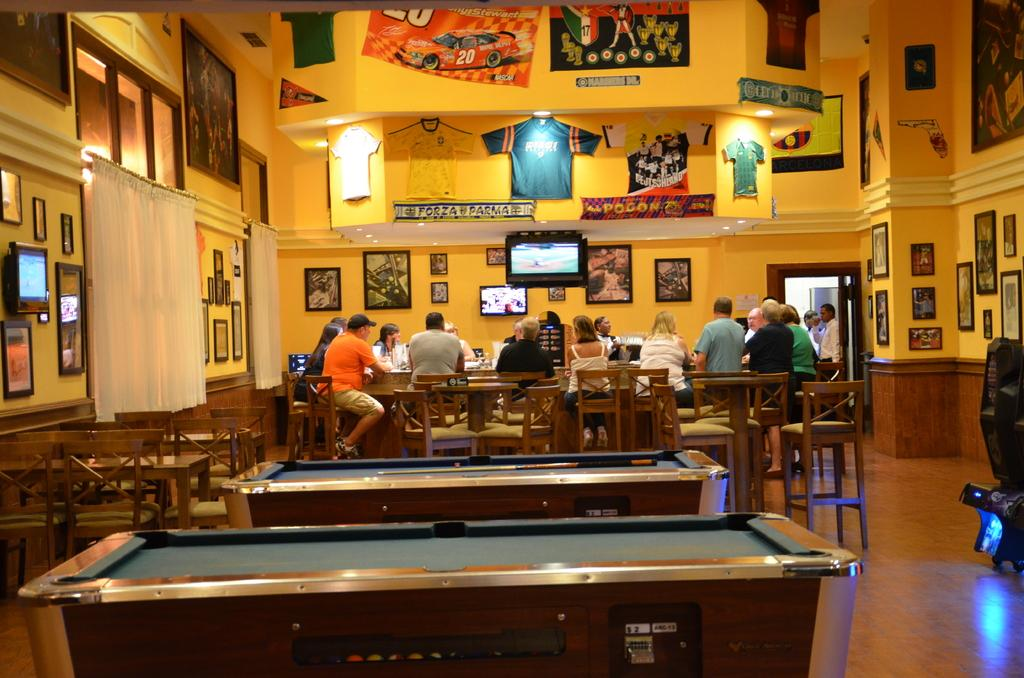What type of furniture is present in the image? There are chairs and tables in the image. What can be seen hanging on the walls? There are frames in the image. What type of clothing is visible in the image? There are shirts in the image. What is the color of the wall in the image? The wall is yellow. What are people doing in the image? People are sitting on chairs. What is placed in front of the chairs? There are boards in front of the chairs. What type of decorations are present in the image? There are lights and banners in the image. Can you tell me how many twigs are lying on the sidewalk in the image? There is no sidewalk or twigs present in the image. What type of voyage is depicted in the image? There is no voyage depicted in the image; it features chairs, tables, lights, frames, shirts, banners, and people sitting on chairs. 